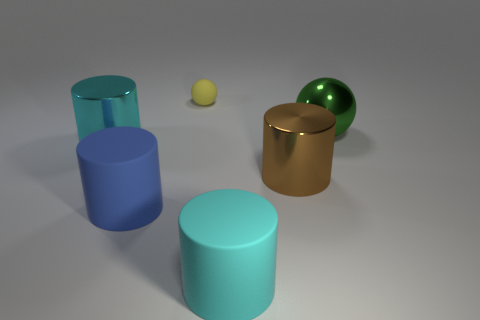What time of day does the lighting in the image suggest? The image does not depict an environment that would indicate a time of day; it's a neutral, artificially lit scene with soft shadows suggesting a light source from above, perhaps from studio lighting. 